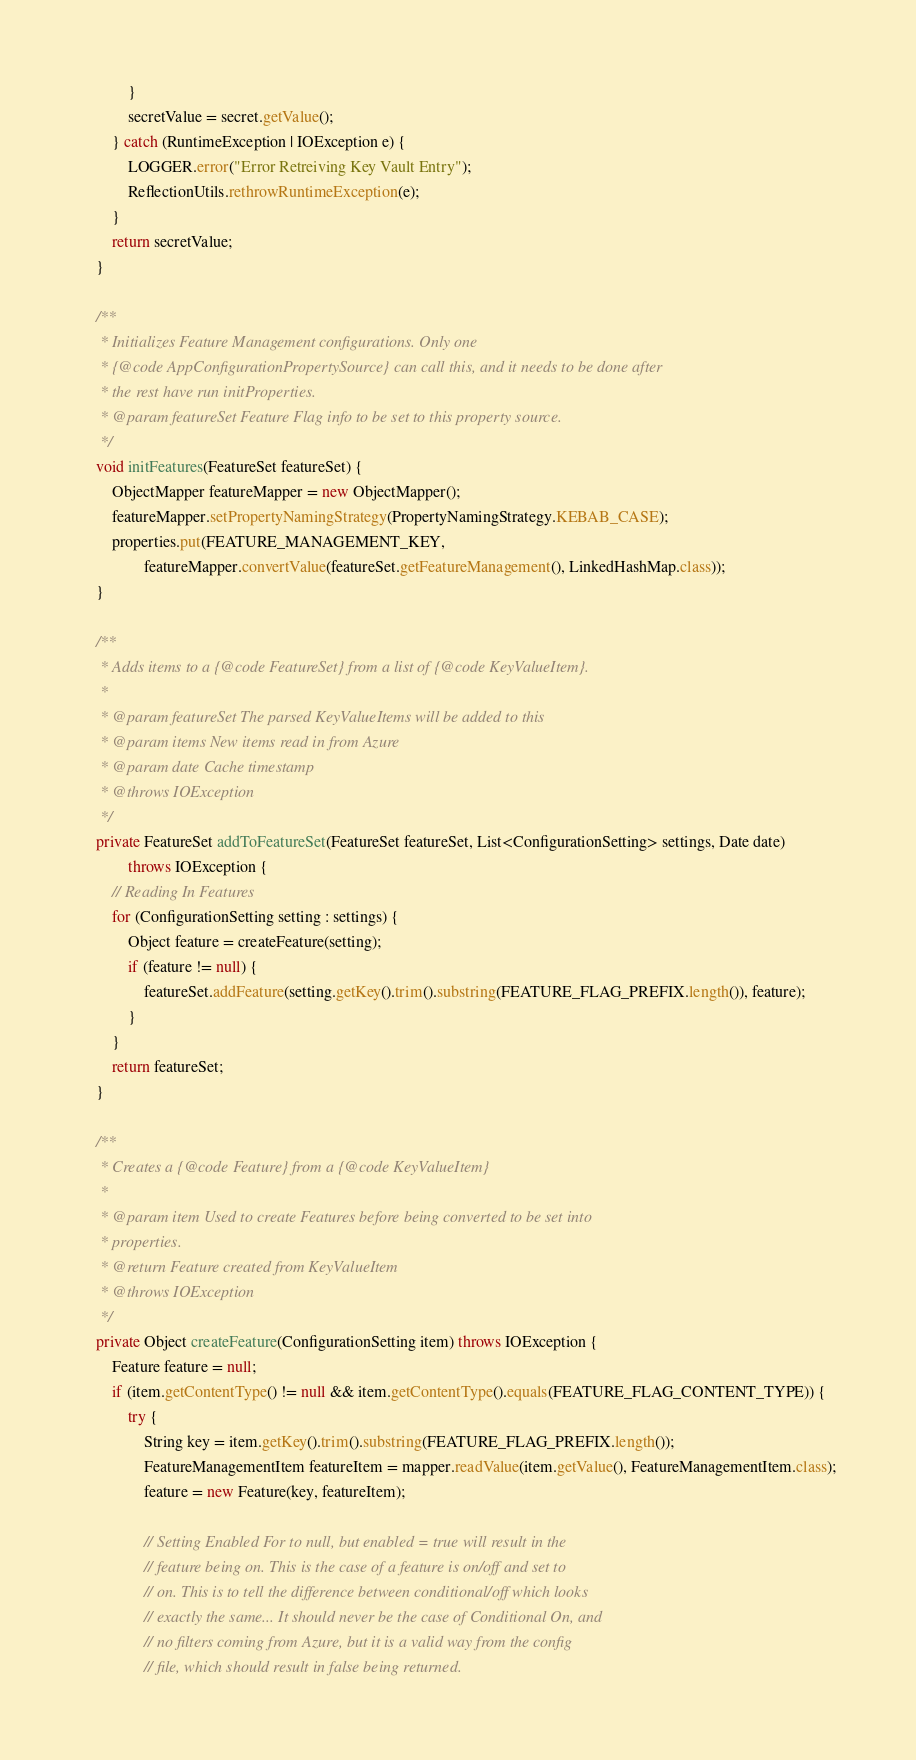<code> <loc_0><loc_0><loc_500><loc_500><_Java_>            }
            secretValue = secret.getValue();
        } catch (RuntimeException | IOException e) {
            LOGGER.error("Error Retreiving Key Vault Entry");
            ReflectionUtils.rethrowRuntimeException(e);
        }
        return secretValue;
    }

    /**
     * Initializes Feature Management configurations. Only one
     * {@code AppConfigurationPropertySource} can call this, and it needs to be done after
     * the rest have run initProperties.
     * @param featureSet Feature Flag info to be set to this property source.
     */
    void initFeatures(FeatureSet featureSet) {
        ObjectMapper featureMapper = new ObjectMapper();
        featureMapper.setPropertyNamingStrategy(PropertyNamingStrategy.KEBAB_CASE);
        properties.put(FEATURE_MANAGEMENT_KEY,
                featureMapper.convertValue(featureSet.getFeatureManagement(), LinkedHashMap.class));
    }

    /**
     * Adds items to a {@code FeatureSet} from a list of {@code KeyValueItem}.
     * 
     * @param featureSet The parsed KeyValueItems will be added to this
     * @param items New items read in from Azure
     * @param date Cache timestamp
     * @throws IOException
     */
    private FeatureSet addToFeatureSet(FeatureSet featureSet, List<ConfigurationSetting> settings, Date date)
            throws IOException {
        // Reading In Features
        for (ConfigurationSetting setting : settings) {
            Object feature = createFeature(setting);
            if (feature != null) {
                featureSet.addFeature(setting.getKey().trim().substring(FEATURE_FLAG_PREFIX.length()), feature);
            }
        }
        return featureSet;
    }

    /**
     * Creates a {@code Feature} from a {@code KeyValueItem}
     * 
     * @param item Used to create Features before being converted to be set into
     * properties.
     * @return Feature created from KeyValueItem
     * @throws IOException
     */
    private Object createFeature(ConfigurationSetting item) throws IOException {
        Feature feature = null;
        if (item.getContentType() != null && item.getContentType().equals(FEATURE_FLAG_CONTENT_TYPE)) {
            try {
                String key = item.getKey().trim().substring(FEATURE_FLAG_PREFIX.length());
                FeatureManagementItem featureItem = mapper.readValue(item.getValue(), FeatureManagementItem.class);
                feature = new Feature(key, featureItem);

                // Setting Enabled For to null, but enabled = true will result in the
                // feature being on. This is the case of a feature is on/off and set to
                // on. This is to tell the difference between conditional/off which looks
                // exactly the same... It should never be the case of Conditional On, and
                // no filters coming from Azure, but it is a valid way from the config
                // file, which should result in false being returned.</code> 